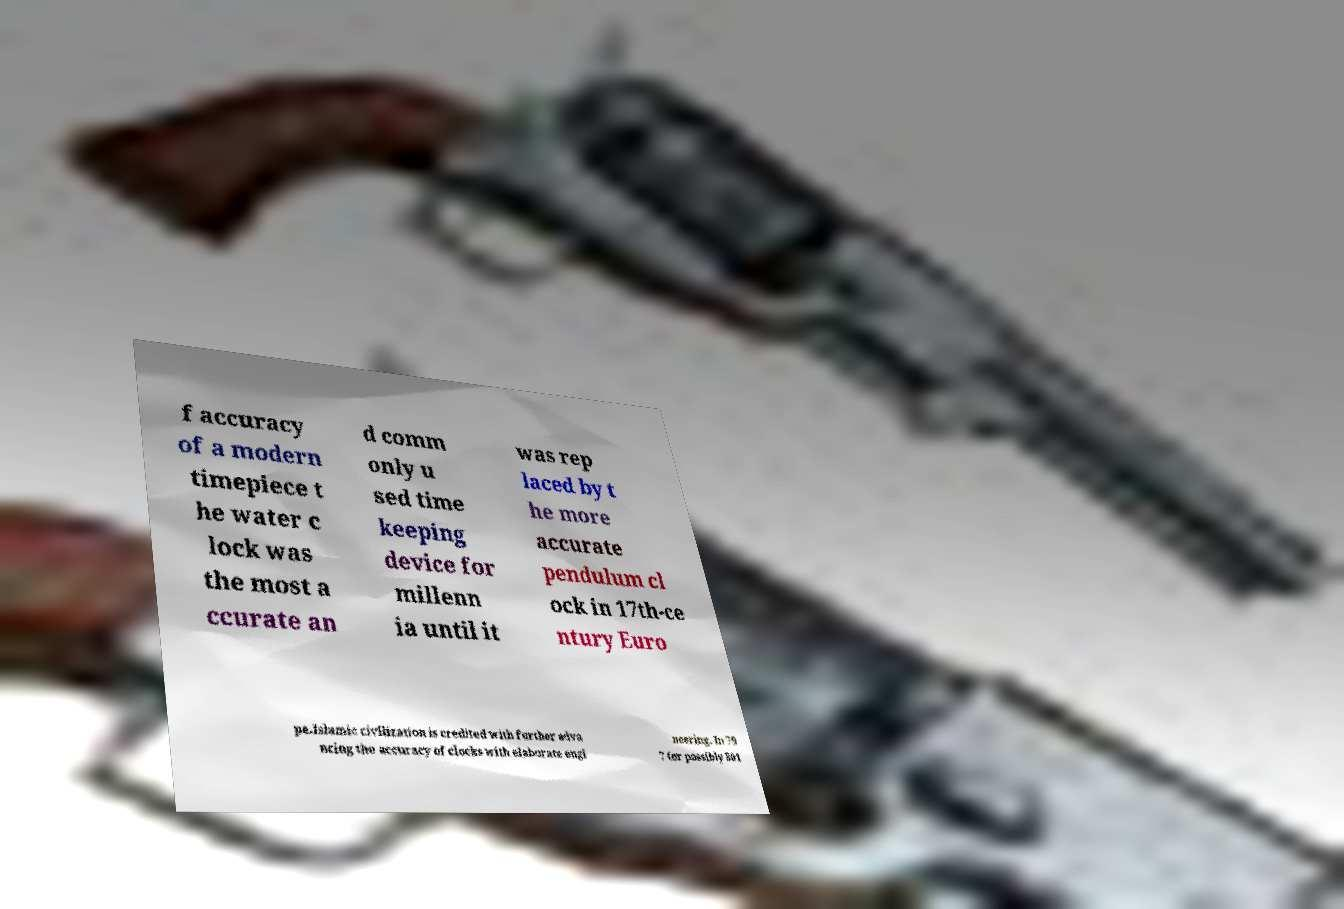What messages or text are displayed in this image? I need them in a readable, typed format. f accuracy of a modern timepiece t he water c lock was the most a ccurate an d comm only u sed time keeping device for millenn ia until it was rep laced by t he more accurate pendulum cl ock in 17th-ce ntury Euro pe.Islamic civilization is credited with further adva ncing the accuracy of clocks with elaborate engi neering. In 79 7 (or possibly 801 